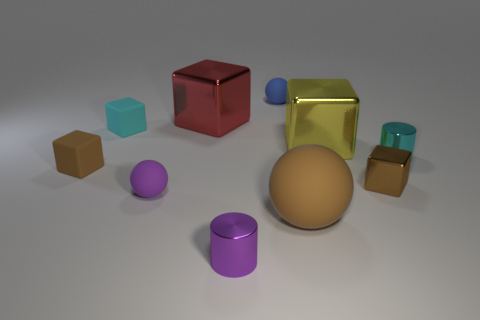There is a big object that is in front of the tiny brown metal object; is it the same shape as the tiny purple object that is on the right side of the large red cube?
Make the answer very short. No. There is a shiny object that is both in front of the brown matte cube and to the right of the large yellow block; what color is it?
Offer a very short reply. Brown. Are there any metal cubes of the same color as the big matte object?
Provide a short and direct response. Yes. What is the color of the small metallic cylinder in front of the small brown shiny object?
Offer a very short reply. Purple. Is there a blue rubber sphere that is in front of the small cube that is right of the big brown object?
Give a very brief answer. No. There is a tiny shiny cube; is it the same color as the matte block that is in front of the tiny cyan metal cylinder?
Offer a very short reply. Yes. Are there any red objects that have the same material as the brown sphere?
Provide a short and direct response. No. How many small blue shiny cylinders are there?
Offer a very short reply. 0. What is the material of the tiny cyan object that is in front of the yellow shiny block that is in front of the red thing?
Offer a terse response. Metal. What color is the other block that is the same material as the cyan cube?
Your answer should be very brief. Brown. 